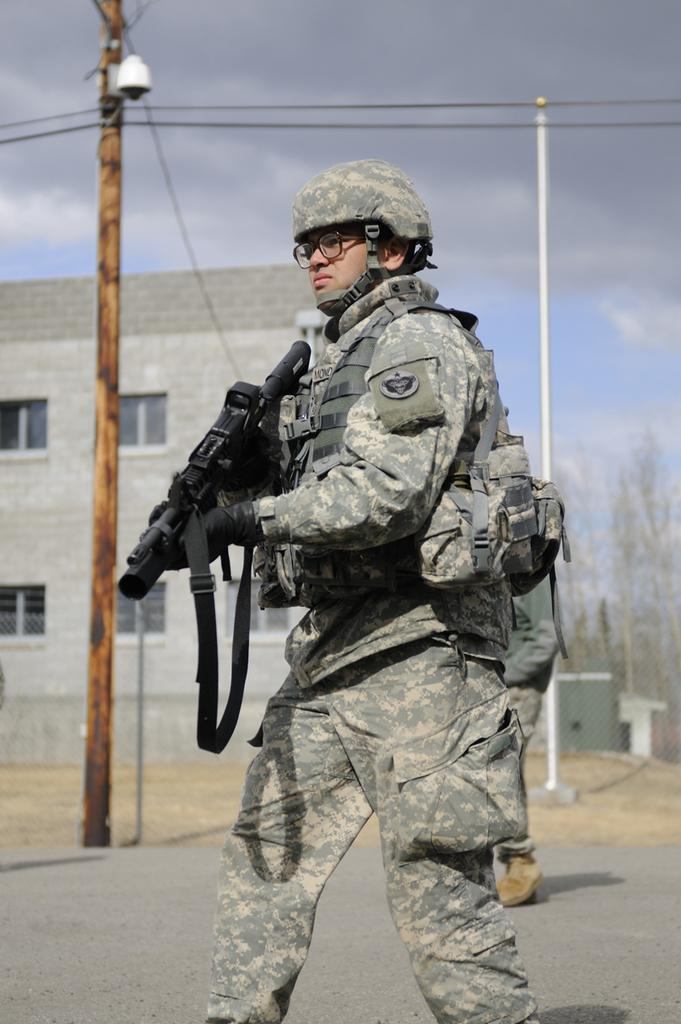What is the main subject of the image? The main subject of the image is an army personnel. What is the army personnel doing in the image? The army personnel is walking in the image. What is the army personnel holding in his hand? The army personnel is holding a gun in his hand. What can be seen in the background of the image? There is an electric pole with cables and a building behind the electric pole in the image. How many sheep are visible in the image? There are no sheep present in the image. What type of locket is the army personnel wearing in the image? The image does not show the army personnel wearing a locket. 